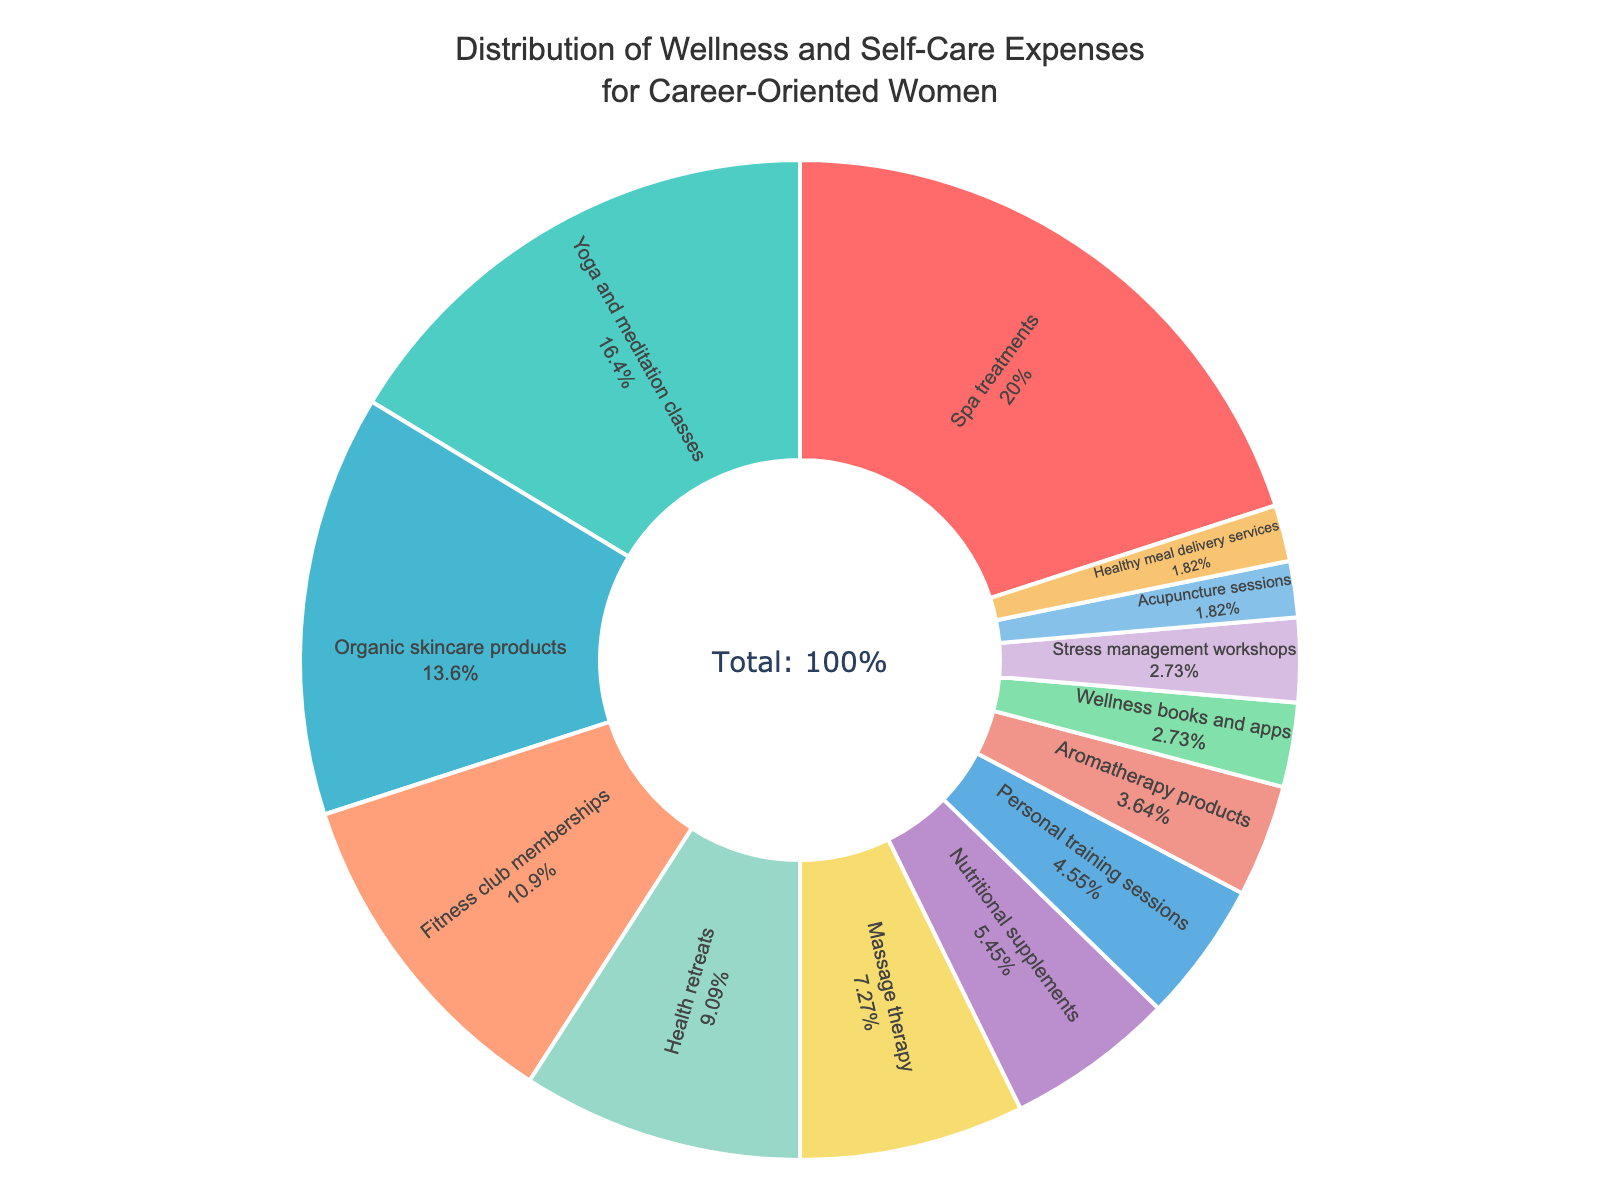What is the category with the highest percentage of expenses? To find the highest category, look at the section of the pie chart with the largest area and the highest percentage label. The "Spa treatments" section shows 22%, which is the highest.
Answer: Spa treatments Which two categories have the smallest percentages, and what is their combined percentage? Identify the two smallest sections of the pie chart, labeled with the lowest percentages. "Acupuncture sessions" and "Healthy meal delivery services" both have 2%. Adding these percentages gives 2% + 2% = 4%.
Answer: Acupuncture sessions and Healthy meal delivery services, 4% Are Spa treatments expenses greater than the combined expenses of Massage therapy and Nutritional supplements? Check the percentage of Spa treatments, which is 22%. Then add the percentages of Massage therapy (8%) and Nutritional supplements (6%): 8% + 6% = 14%. Since 22% > 14%, Spa treatments expenses are greater.
Answer: Yes What percentage of expenses is attributed to wellness books and apps and stress management workshops combined? Find the percentage for both "Wellness books and apps" (3%) and "Stress management workshops" (3%), then add them: 3% + 3% = 6%.
Answer: 6% Is the percentage of expenses for Yoga and meditation classes higher than that for Fitness club memberships? Compare the two percentages: Yoga and meditation classes (18%) and Fitness club memberships (12%). Since 18% > 12%, the answer is yes.
Answer: Yes What is the cumulative percentage of expenses for categories that have 5% or less? Sum the percentages of categories with 5% or less: Personal training sessions (5%), Aromatherapy products (4%), Wellness books and apps (3%), Stress management workshops (3%), Acupuncture sessions (2%), and Healthy meal delivery services (2%). 5% + 4% + 3% + 3% + 2% + 2% = 19%.
Answer: 19% How much greater is the percentage of expenses on Spa treatments compared to Organic skincare products? Subtract the percentage of Organic skincare products (15%) from Spa treatments (22%): 22% - 15% = 7%.
Answer: 7% Which category has the 4th largest percentage of expenses? Identify the fourth-largest segment by arranging the percentages in descending order: Spa treatments (22%), Yoga and meditation classes (18%), Organic skincare products (15%), and then Fitness club memberships (12%). Thus, Fitness club memberships is the fourth largest.
Answer: Fitness club memberships What is the combined percentage of expenses for categories related to physical activity (Yoga and meditation classes, Fitness club memberships, Personal training sessions)? Add the percentages for Yoga and meditation classes (18%), Fitness club memberships (12%), and Personal training sessions (5%): 18% + 12% + 5% = 35%.
Answer: 35% Are the combined expenses on Health retreats and Massage therapy more than the expenses on Organic skincare products? Add the percentages of Health retreats (10%) and Massage therapy (8%): 10% + 8% = 18%. Compare 18% to Organic skincare products (15%), and since 18% > 15%, the combined expenses are more.
Answer: Yes 